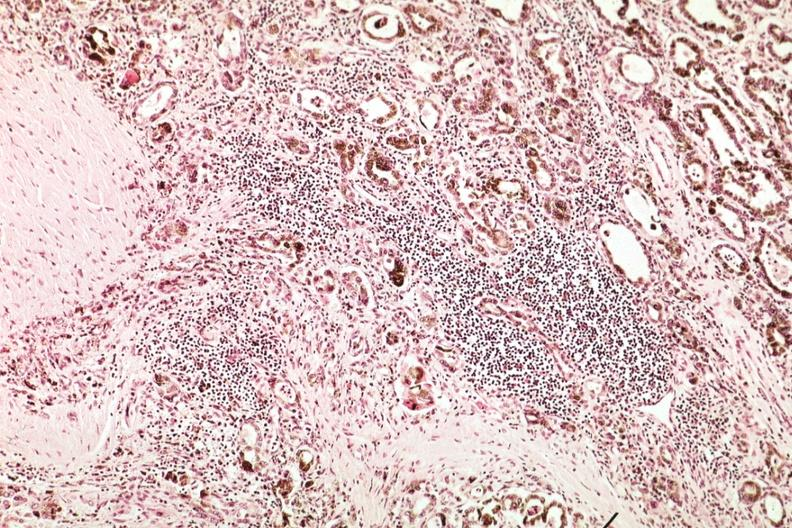s thyroid present?
Answer the question using a single word or phrase. Yes 